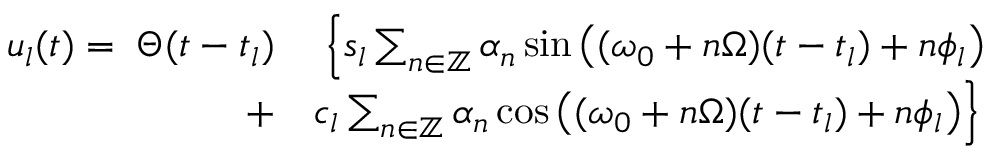<formula> <loc_0><loc_0><loc_500><loc_500>\begin{array} { r l } { u _ { l } ( t ) = \, \Theta ( t - t _ { l } ) } & { \, \left \{ s _ { l } \sum _ { n \in \mathbb { Z } } \alpha _ { n } \sin \left ( ( \omega _ { 0 } + n \Omega ) ( t - t _ { l } ) + n \phi _ { l } \right ) } \\ { + } & { c _ { l } \sum _ { n \in \mathbb { Z } } \alpha _ { n } \cos \left ( ( \omega _ { 0 } + n \Omega ) ( t - t _ { l } ) + n \phi _ { l } \right ) \right \} } \end{array}</formula> 